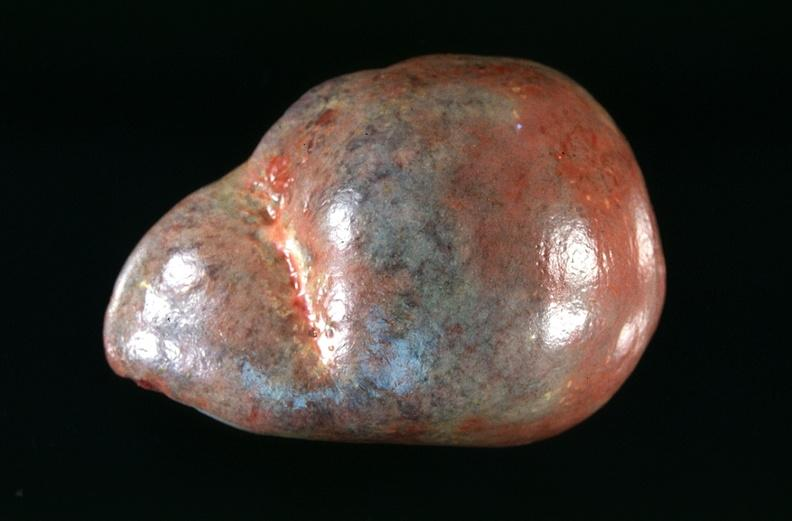how many antitrypsin does this image show spleen, congestion in a patient with disseminated intravascular coagulation and alpha-deficiency?
Answer the question using a single word or phrase. 1 